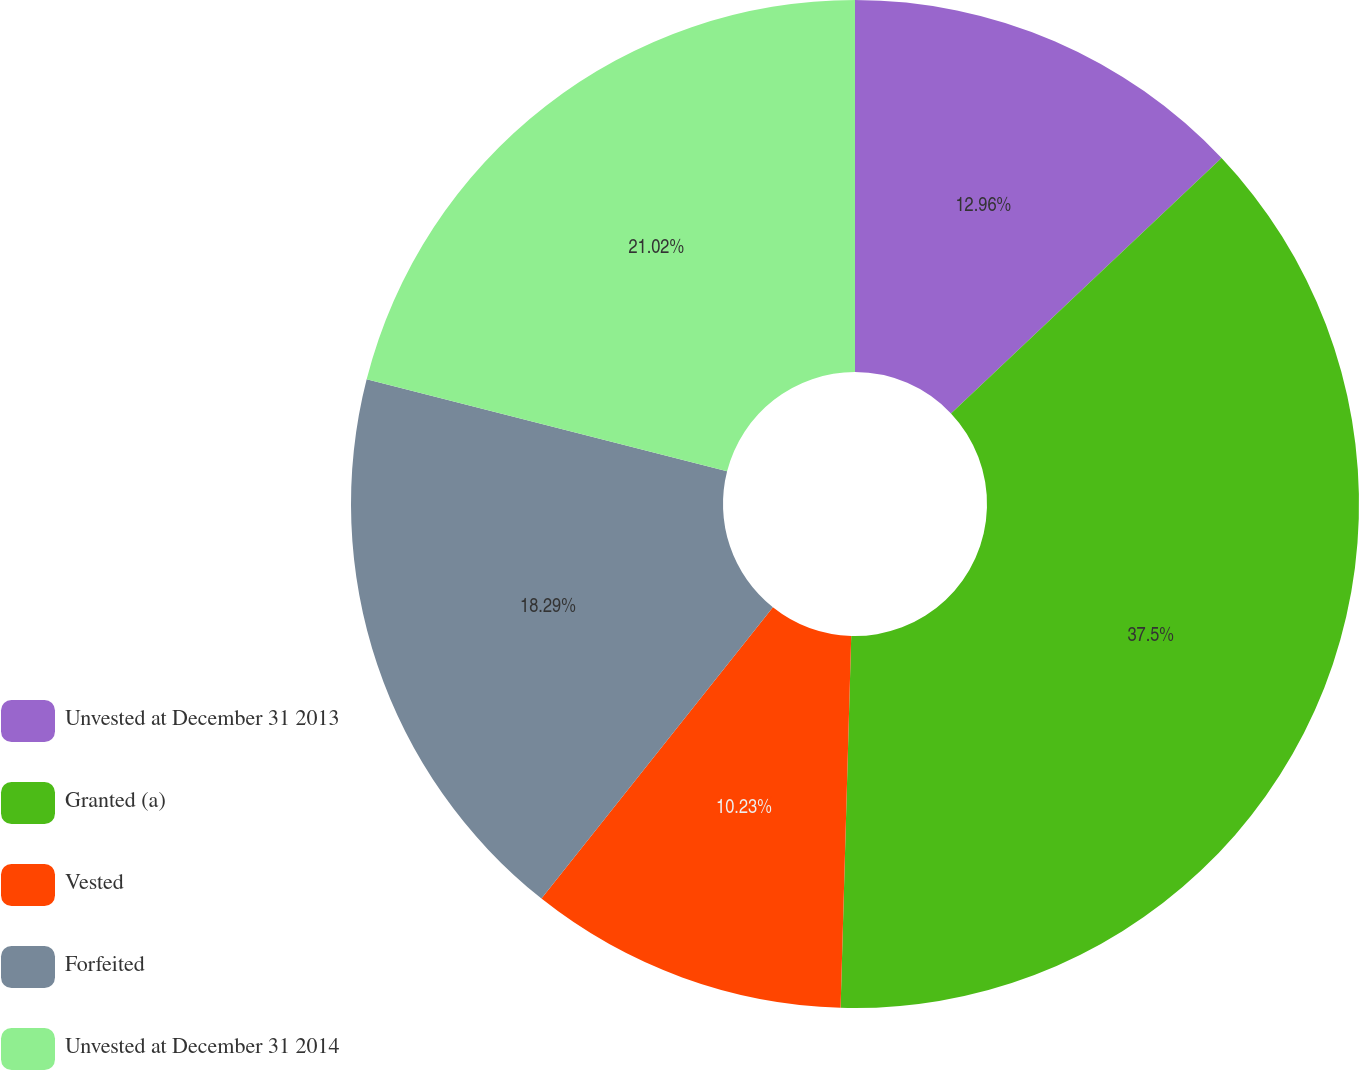Convert chart. <chart><loc_0><loc_0><loc_500><loc_500><pie_chart><fcel>Unvested at December 31 2013<fcel>Granted (a)<fcel>Vested<fcel>Forfeited<fcel>Unvested at December 31 2014<nl><fcel>12.96%<fcel>37.49%<fcel>10.23%<fcel>18.29%<fcel>21.02%<nl></chart> 